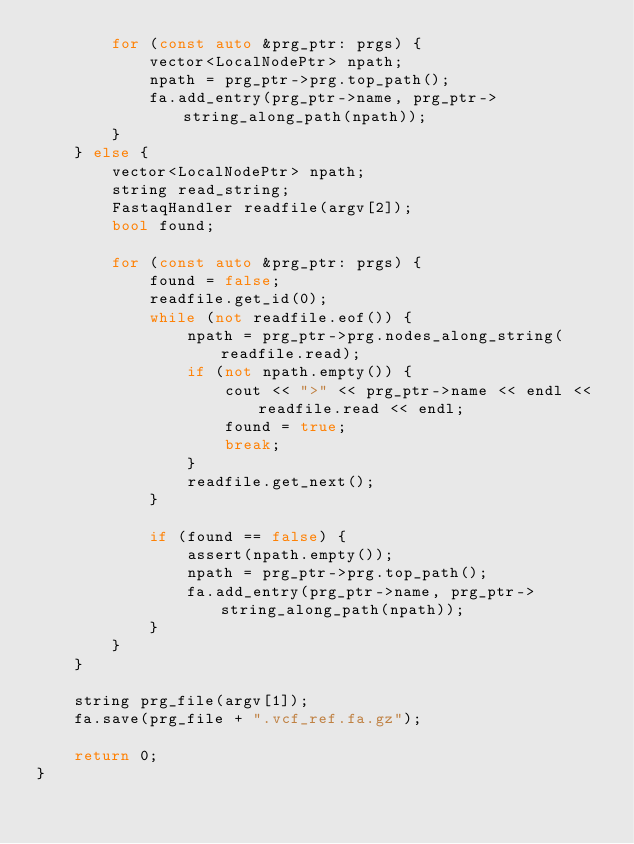<code> <loc_0><loc_0><loc_500><loc_500><_C++_>        for (const auto &prg_ptr: prgs) {
            vector<LocalNodePtr> npath;
            npath = prg_ptr->prg.top_path();
            fa.add_entry(prg_ptr->name, prg_ptr->string_along_path(npath));
        }
    } else {
        vector<LocalNodePtr> npath;
        string read_string;
        FastaqHandler readfile(argv[2]);
        bool found;

        for (const auto &prg_ptr: prgs) {
            found = false;
            readfile.get_id(0);
            while (not readfile.eof()) {
                npath = prg_ptr->prg.nodes_along_string(readfile.read);
                if (not npath.empty()) {
                    cout << ">" << prg_ptr->name << endl << readfile.read << endl;
                    found = true;
                    break;
                }
                readfile.get_next();
            }

            if (found == false) {
                assert(npath.empty());
                npath = prg_ptr->prg.top_path();
                fa.add_entry(prg_ptr->name, prg_ptr->string_along_path(npath));
            }
        }
    }

    string prg_file(argv[1]);
    fa.save(prg_file + ".vcf_ref.fa.gz");

    return 0;
}

</code> 